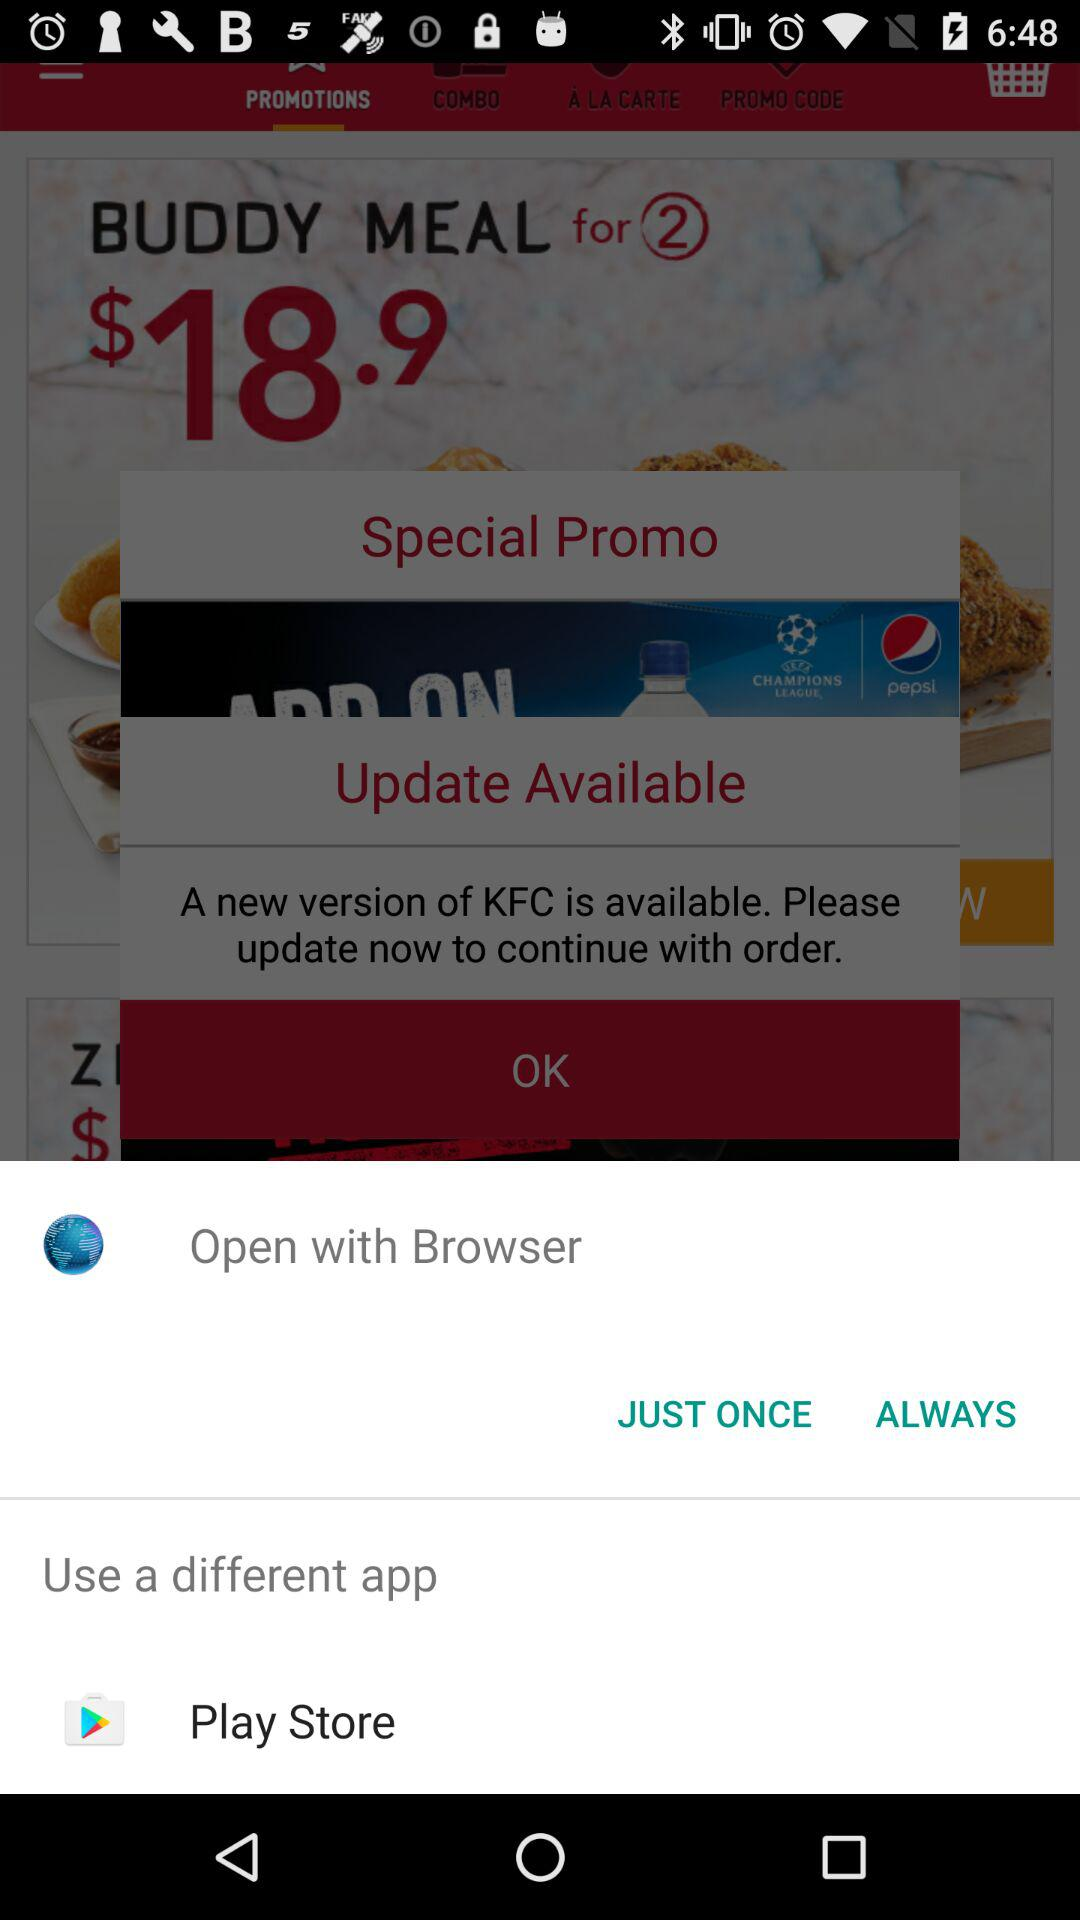What is the price of the "BUDDY MEAL" for 2? The price of the "BUDDY MEAL" for 2 is $18.9. 